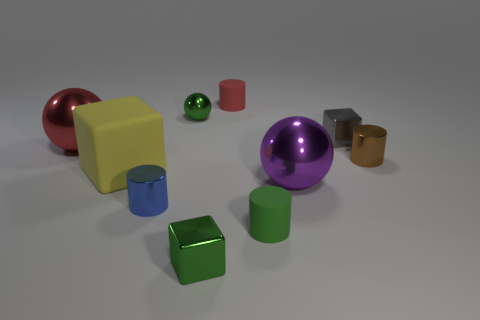The purple metallic object is what size?
Offer a terse response. Large. What color is the other tiny block that is made of the same material as the small green block?
Offer a very short reply. Gray. What number of small green cubes have the same material as the small blue object?
Provide a succinct answer. 1. What number of things are large blue matte cylinders or small cubes behind the tiny brown shiny object?
Provide a short and direct response. 1. Do the big thing that is on the right side of the red cylinder and the large red sphere have the same material?
Provide a short and direct response. Yes. There is a metal ball that is the same size as the red matte cylinder; what is its color?
Ensure brevity in your answer.  Green. Are there any red metal objects of the same shape as the large yellow rubber object?
Offer a very short reply. No. The shiny block behind the large object that is on the right side of the tiny metallic cylinder that is left of the large purple shiny thing is what color?
Offer a terse response. Gray. What number of matte things are either tiny green cylinders or large blocks?
Give a very brief answer. 2. Is the number of big metal spheres that are on the left side of the big cube greater than the number of tiny green shiny objects to the right of the brown thing?
Your answer should be very brief. Yes. 